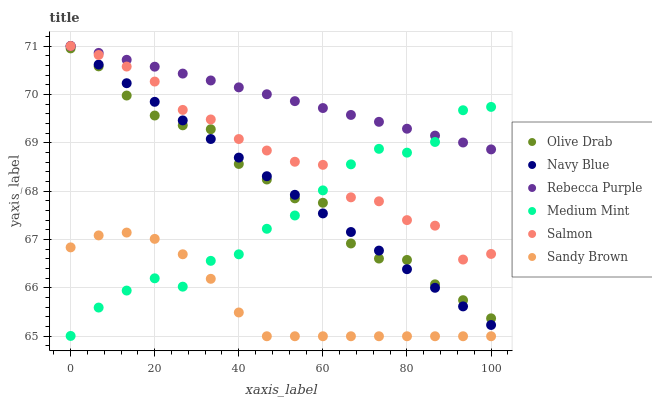Does Sandy Brown have the minimum area under the curve?
Answer yes or no. Yes. Does Rebecca Purple have the maximum area under the curve?
Answer yes or no. Yes. Does Navy Blue have the minimum area under the curve?
Answer yes or no. No. Does Navy Blue have the maximum area under the curve?
Answer yes or no. No. Is Navy Blue the smoothest?
Answer yes or no. Yes. Is Medium Mint the roughest?
Answer yes or no. Yes. Is Salmon the smoothest?
Answer yes or no. No. Is Salmon the roughest?
Answer yes or no. No. Does Sandy Brown have the lowest value?
Answer yes or no. Yes. Does Navy Blue have the lowest value?
Answer yes or no. No. Does Rebecca Purple have the highest value?
Answer yes or no. Yes. Does Sandy Brown have the highest value?
Answer yes or no. No. Is Sandy Brown less than Olive Drab?
Answer yes or no. Yes. Is Salmon greater than Olive Drab?
Answer yes or no. Yes. Does Salmon intersect Navy Blue?
Answer yes or no. Yes. Is Salmon less than Navy Blue?
Answer yes or no. No. Is Salmon greater than Navy Blue?
Answer yes or no. No. Does Sandy Brown intersect Olive Drab?
Answer yes or no. No. 